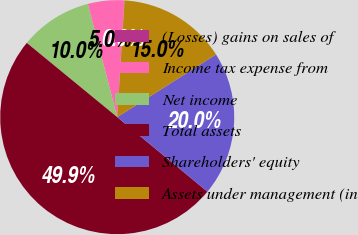Convert chart. <chart><loc_0><loc_0><loc_500><loc_500><pie_chart><fcel>(Losses) gains on sales of<fcel>Income tax expense from<fcel>Net income<fcel>Total assets<fcel>Shareholders' equity<fcel>Assets under management (in<nl><fcel>0.03%<fcel>5.02%<fcel>10.01%<fcel>49.94%<fcel>19.99%<fcel>15.0%<nl></chart> 